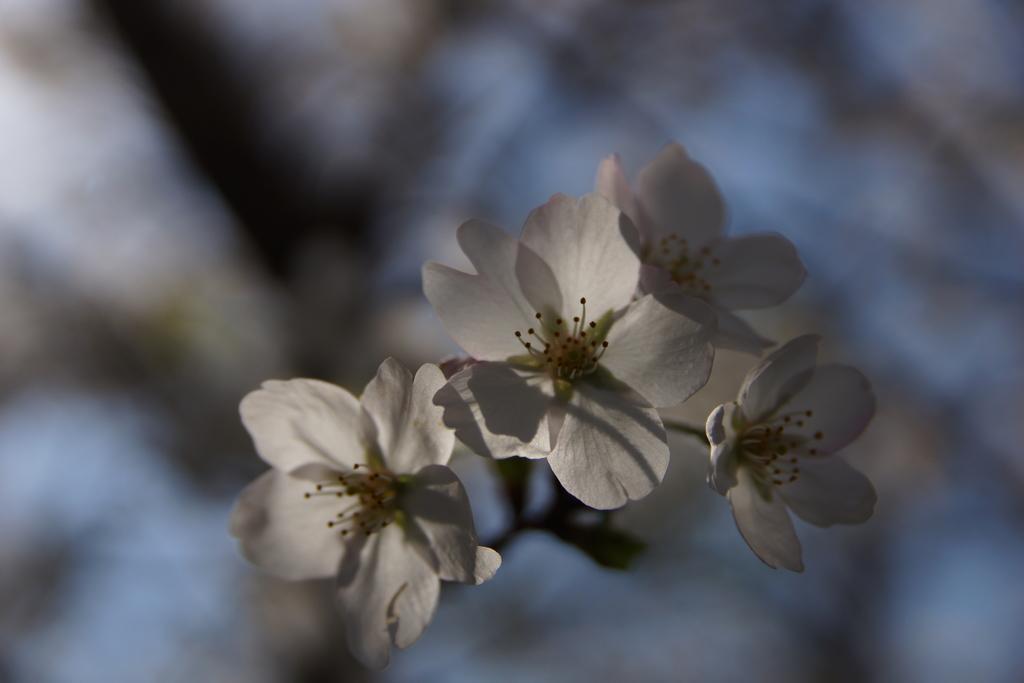Can you describe this image briefly? In this image we can see flowers. There is a blur background. 